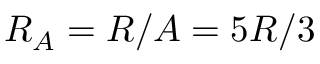<formula> <loc_0><loc_0><loc_500><loc_500>R _ { A } = R / A = 5 R / 3</formula> 